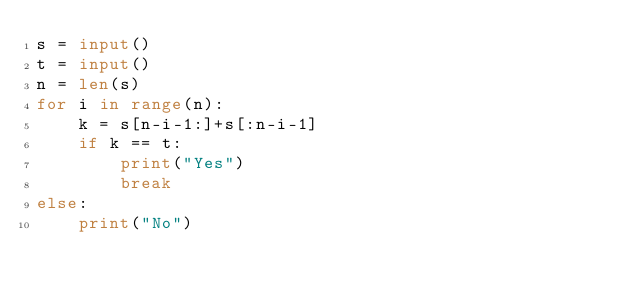Convert code to text. <code><loc_0><loc_0><loc_500><loc_500><_Python_>s = input()
t = input()
n = len(s)
for i in range(n):
    k = s[n-i-1:]+s[:n-i-1]
    if k == t:
        print("Yes")
        break
else:
    print("No")</code> 